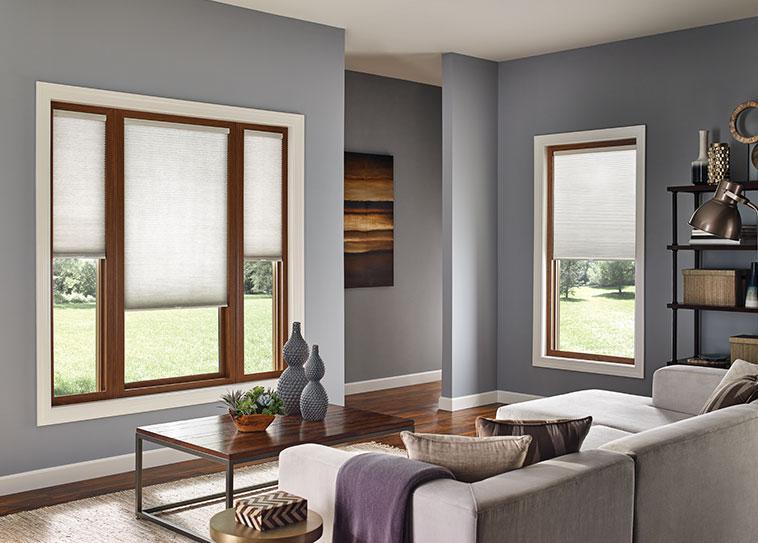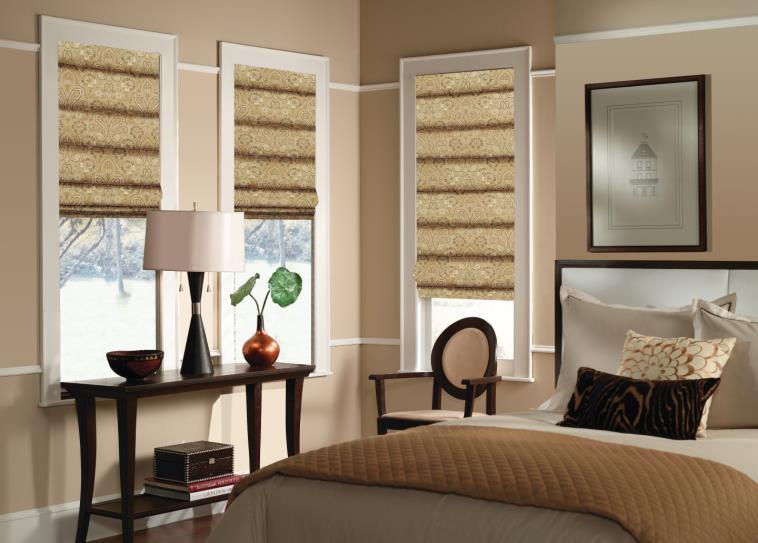The first image is the image on the left, the second image is the image on the right. Examine the images to the left and right. Is the description "There is at least one plant in the right image" accurate? Answer yes or no. Yes. The first image is the image on the left, the second image is the image on the right. For the images displayed, is the sentence "In at least one image there are three blinds with two at the same height." factually correct? Answer yes or no. Yes. 